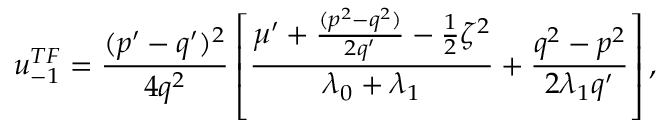Convert formula to latex. <formula><loc_0><loc_0><loc_500><loc_500>u _ { - 1 } ^ { T F } = \frac { ( p ^ { \prime } - q ^ { \prime } ) ^ { 2 } } { 4 q ^ { 2 } } \left [ \frac { \mu ^ { \prime } + \frac { ( p ^ { 2 } - q ^ { 2 } ) } { 2 q ^ { \prime } } - \frac { 1 } { 2 } \zeta ^ { 2 } } { \lambda _ { 0 } + \lambda _ { 1 } } + \frac { q ^ { 2 } - p ^ { 2 } } { 2 \lambda _ { 1 } q ^ { \prime } } \right ] ,</formula> 